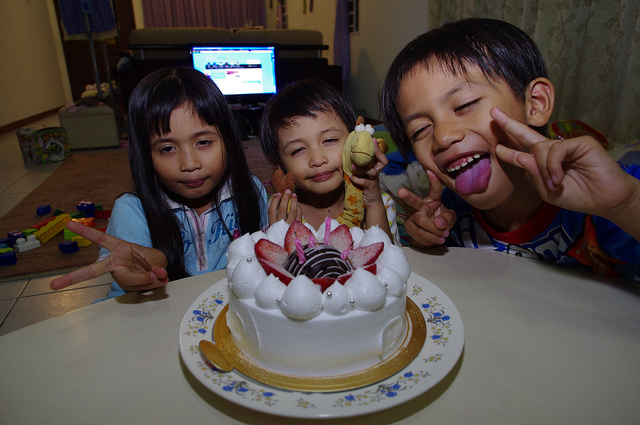<image>What color are the dolls eyes? I am not sure what color the doll's eyes are. They could be white or black. What color are the dolls eyes? I don't know what color the doll's eyes are. It can be either white or black. 